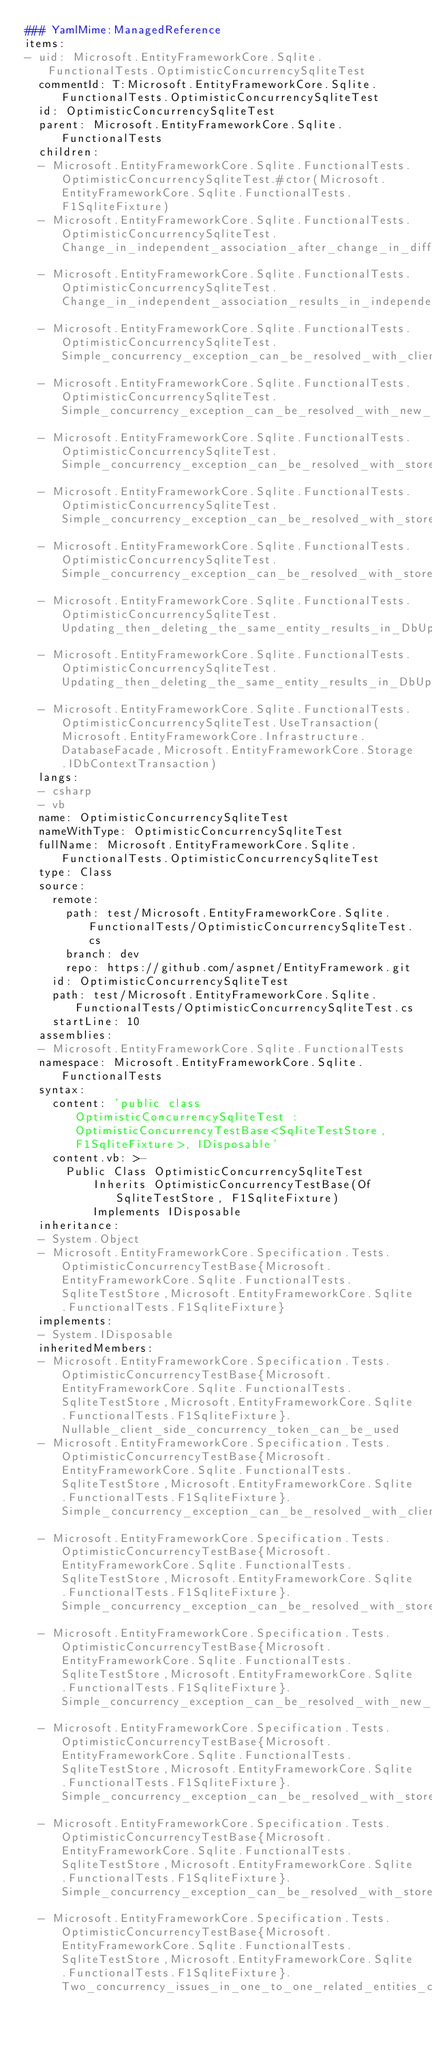Convert code to text. <code><loc_0><loc_0><loc_500><loc_500><_YAML_>### YamlMime:ManagedReference
items:
- uid: Microsoft.EntityFrameworkCore.Sqlite.FunctionalTests.OptimisticConcurrencySqliteTest
  commentId: T:Microsoft.EntityFrameworkCore.Sqlite.FunctionalTests.OptimisticConcurrencySqliteTest
  id: OptimisticConcurrencySqliteTest
  parent: Microsoft.EntityFrameworkCore.Sqlite.FunctionalTests
  children:
  - Microsoft.EntityFrameworkCore.Sqlite.FunctionalTests.OptimisticConcurrencySqliteTest.#ctor(Microsoft.EntityFrameworkCore.Sqlite.FunctionalTests.F1SqliteFixture)
  - Microsoft.EntityFrameworkCore.Sqlite.FunctionalTests.OptimisticConcurrencySqliteTest.Change_in_independent_association_after_change_in_different_concurrency_token_results_in_independent_association_exception
  - Microsoft.EntityFrameworkCore.Sqlite.FunctionalTests.OptimisticConcurrencySqliteTest.Change_in_independent_association_results_in_independent_association_exception
  - Microsoft.EntityFrameworkCore.Sqlite.FunctionalTests.OptimisticConcurrencySqliteTest.Simple_concurrency_exception_can_be_resolved_with_client_values
  - Microsoft.EntityFrameworkCore.Sqlite.FunctionalTests.OptimisticConcurrencySqliteTest.Simple_concurrency_exception_can_be_resolved_with_new_values
  - Microsoft.EntityFrameworkCore.Sqlite.FunctionalTests.OptimisticConcurrencySqliteTest.Simple_concurrency_exception_can_be_resolved_with_store_values
  - Microsoft.EntityFrameworkCore.Sqlite.FunctionalTests.OptimisticConcurrencySqliteTest.Simple_concurrency_exception_can_be_resolved_with_store_values_using_equivalent_of_accept_changes
  - Microsoft.EntityFrameworkCore.Sqlite.FunctionalTests.OptimisticConcurrencySqliteTest.Simple_concurrency_exception_can_be_resolved_with_store_values_using_Reload
  - Microsoft.EntityFrameworkCore.Sqlite.FunctionalTests.OptimisticConcurrencySqliteTest.Updating_then_deleting_the_same_entity_results_in_DbUpdateConcurrencyException
  - Microsoft.EntityFrameworkCore.Sqlite.FunctionalTests.OptimisticConcurrencySqliteTest.Updating_then_deleting_the_same_entity_results_in_DbUpdateConcurrencyException_which_can_be_resolved_with_store_values
  - Microsoft.EntityFrameworkCore.Sqlite.FunctionalTests.OptimisticConcurrencySqliteTest.UseTransaction(Microsoft.EntityFrameworkCore.Infrastructure.DatabaseFacade,Microsoft.EntityFrameworkCore.Storage.IDbContextTransaction)
  langs:
  - csharp
  - vb
  name: OptimisticConcurrencySqliteTest
  nameWithType: OptimisticConcurrencySqliteTest
  fullName: Microsoft.EntityFrameworkCore.Sqlite.FunctionalTests.OptimisticConcurrencySqliteTest
  type: Class
  source:
    remote:
      path: test/Microsoft.EntityFrameworkCore.Sqlite.FunctionalTests/OptimisticConcurrencySqliteTest.cs
      branch: dev
      repo: https://github.com/aspnet/EntityFramework.git
    id: OptimisticConcurrencySqliteTest
    path: test/Microsoft.EntityFrameworkCore.Sqlite.FunctionalTests/OptimisticConcurrencySqliteTest.cs
    startLine: 10
  assemblies:
  - Microsoft.EntityFrameworkCore.Sqlite.FunctionalTests
  namespace: Microsoft.EntityFrameworkCore.Sqlite.FunctionalTests
  syntax:
    content: 'public class OptimisticConcurrencySqliteTest : OptimisticConcurrencyTestBase<SqliteTestStore, F1SqliteFixture>, IDisposable'
    content.vb: >-
      Public Class OptimisticConcurrencySqliteTest
          Inherits OptimisticConcurrencyTestBase(Of SqliteTestStore, F1SqliteFixture)
          Implements IDisposable
  inheritance:
  - System.Object
  - Microsoft.EntityFrameworkCore.Specification.Tests.OptimisticConcurrencyTestBase{Microsoft.EntityFrameworkCore.Sqlite.FunctionalTests.SqliteTestStore,Microsoft.EntityFrameworkCore.Sqlite.FunctionalTests.F1SqliteFixture}
  implements:
  - System.IDisposable
  inheritedMembers:
  - Microsoft.EntityFrameworkCore.Specification.Tests.OptimisticConcurrencyTestBase{Microsoft.EntityFrameworkCore.Sqlite.FunctionalTests.SqliteTestStore,Microsoft.EntityFrameworkCore.Sqlite.FunctionalTests.F1SqliteFixture}.Nullable_client_side_concurrency_token_can_be_used
  - Microsoft.EntityFrameworkCore.Specification.Tests.OptimisticConcurrencyTestBase{Microsoft.EntityFrameworkCore.Sqlite.FunctionalTests.SqliteTestStore,Microsoft.EntityFrameworkCore.Sqlite.FunctionalTests.F1SqliteFixture}.Simple_concurrency_exception_can_be_resolved_with_client_values
  - Microsoft.EntityFrameworkCore.Specification.Tests.OptimisticConcurrencyTestBase{Microsoft.EntityFrameworkCore.Sqlite.FunctionalTests.SqliteTestStore,Microsoft.EntityFrameworkCore.Sqlite.FunctionalTests.F1SqliteFixture}.Simple_concurrency_exception_can_be_resolved_with_store_values
  - Microsoft.EntityFrameworkCore.Specification.Tests.OptimisticConcurrencyTestBase{Microsoft.EntityFrameworkCore.Sqlite.FunctionalTests.SqliteTestStore,Microsoft.EntityFrameworkCore.Sqlite.FunctionalTests.F1SqliteFixture}.Simple_concurrency_exception_can_be_resolved_with_new_values
  - Microsoft.EntityFrameworkCore.Specification.Tests.OptimisticConcurrencyTestBase{Microsoft.EntityFrameworkCore.Sqlite.FunctionalTests.SqliteTestStore,Microsoft.EntityFrameworkCore.Sqlite.FunctionalTests.F1SqliteFixture}.Simple_concurrency_exception_can_be_resolved_with_store_values_using_equivalent_of_accept_changes
  - Microsoft.EntityFrameworkCore.Specification.Tests.OptimisticConcurrencyTestBase{Microsoft.EntityFrameworkCore.Sqlite.FunctionalTests.SqliteTestStore,Microsoft.EntityFrameworkCore.Sqlite.FunctionalTests.F1SqliteFixture}.Simple_concurrency_exception_can_be_resolved_with_store_values_using_Reload
  - Microsoft.EntityFrameworkCore.Specification.Tests.OptimisticConcurrencyTestBase{Microsoft.EntityFrameworkCore.Sqlite.FunctionalTests.SqliteTestStore,Microsoft.EntityFrameworkCore.Sqlite.FunctionalTests.F1SqliteFixture}.Two_concurrency_issues_in_one_to_one_related_entities_can_be_handled_by_dealing_with_dependent_first</code> 